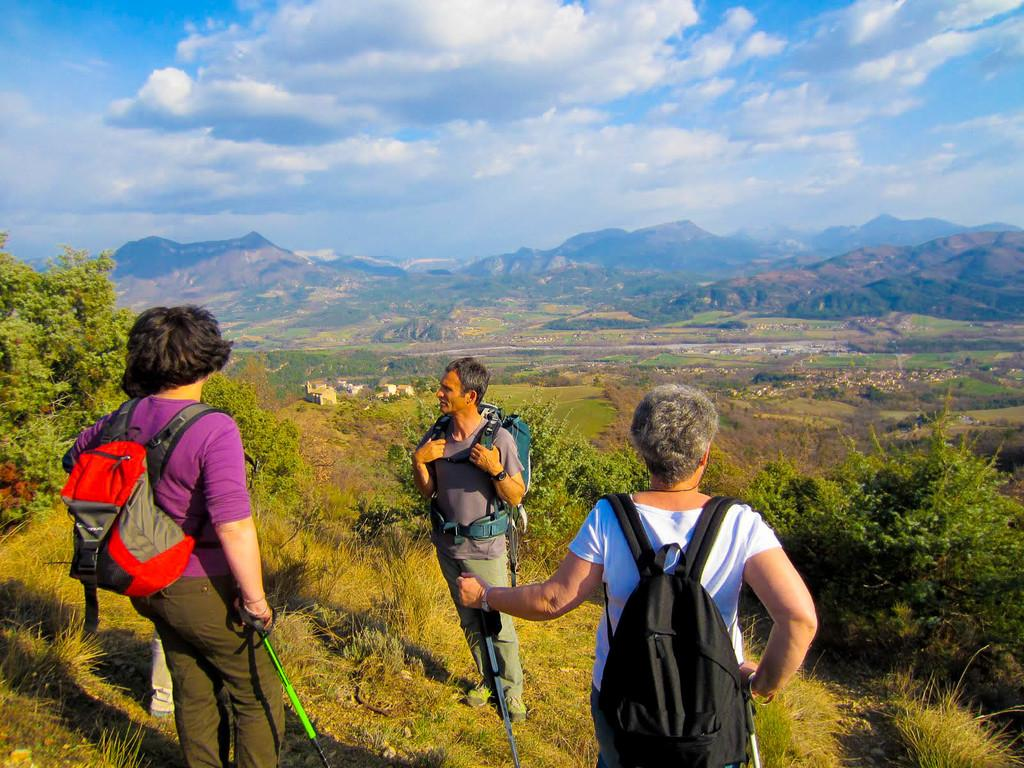What can be seen in the background of the image? In the background of the image, there is a sky with clouds, trees, hills, and grass. What is the primary feature of the sky in the image? The primary feature of the sky in the image is the presence of clouds. What type of terrain is visible in the image? The terrain visible in the image includes hills and grass. How many people are present in the image? There are three people standing in the image. What type of guitar can be seen floating in the water near the trees? There is no guitar present in the image; it only features people, trees, hills, grass, and a sky with clouds. 